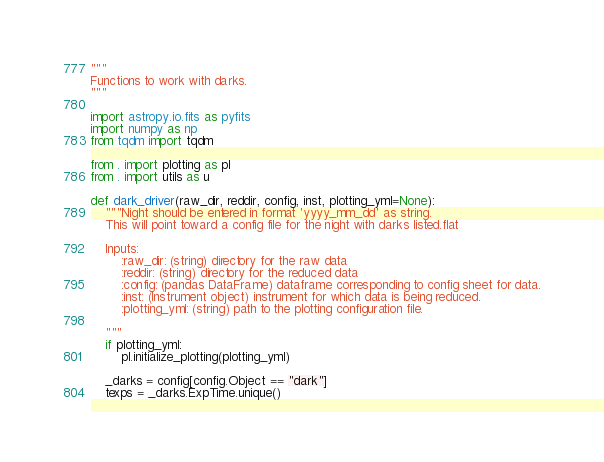Convert code to text. <code><loc_0><loc_0><loc_500><loc_500><_Python_>"""
Functions to work with darks.
"""

import astropy.io.fits as pyfits
import numpy as np
from tqdm import tqdm

from . import plotting as pl
from . import utils as u

def dark_driver(raw_dir, reddir, config, inst, plotting_yml=None):
    """Night should be entered in format 'yyyy_mm_dd' as string.
    This will point toward a config file for the night with darks listed.flat

    Inputs:
        :raw_dir: (string) directory for the raw data
        :reddir: (string) directory for the reduced data
        :config: (pandas DataFrame) dataframe corresponding to config sheet for data.
        :inst: (Instrument object) instrument for which data is being reduced.
        :plotting_yml: (string) path to the plotting configuration file.

    """
    if plotting_yml:
        pl.initialize_plotting(plotting_yml)

    _darks = config[config.Object == "dark"]
    texps = _darks.ExpTime.unique()
</code> 